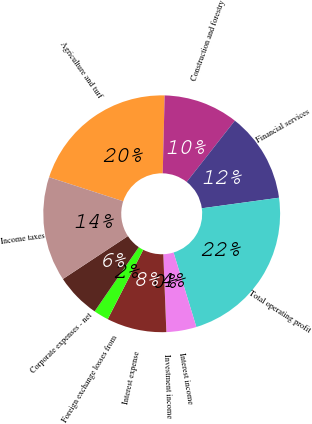Convert chart. <chart><loc_0><loc_0><loc_500><loc_500><pie_chart><fcel>Agriculture and turf<fcel>Construction and forestry<fcel>Financial services<fcel>Total operating profit<fcel>Interest income<fcel>Investment income<fcel>Interest expense<fcel>Foreign exchange losses from<fcel>Corporate expenses - net<fcel>Income taxes<nl><fcel>20.4%<fcel>10.2%<fcel>12.24%<fcel>22.44%<fcel>4.09%<fcel>0.01%<fcel>8.16%<fcel>2.05%<fcel>6.13%<fcel>14.28%<nl></chart> 